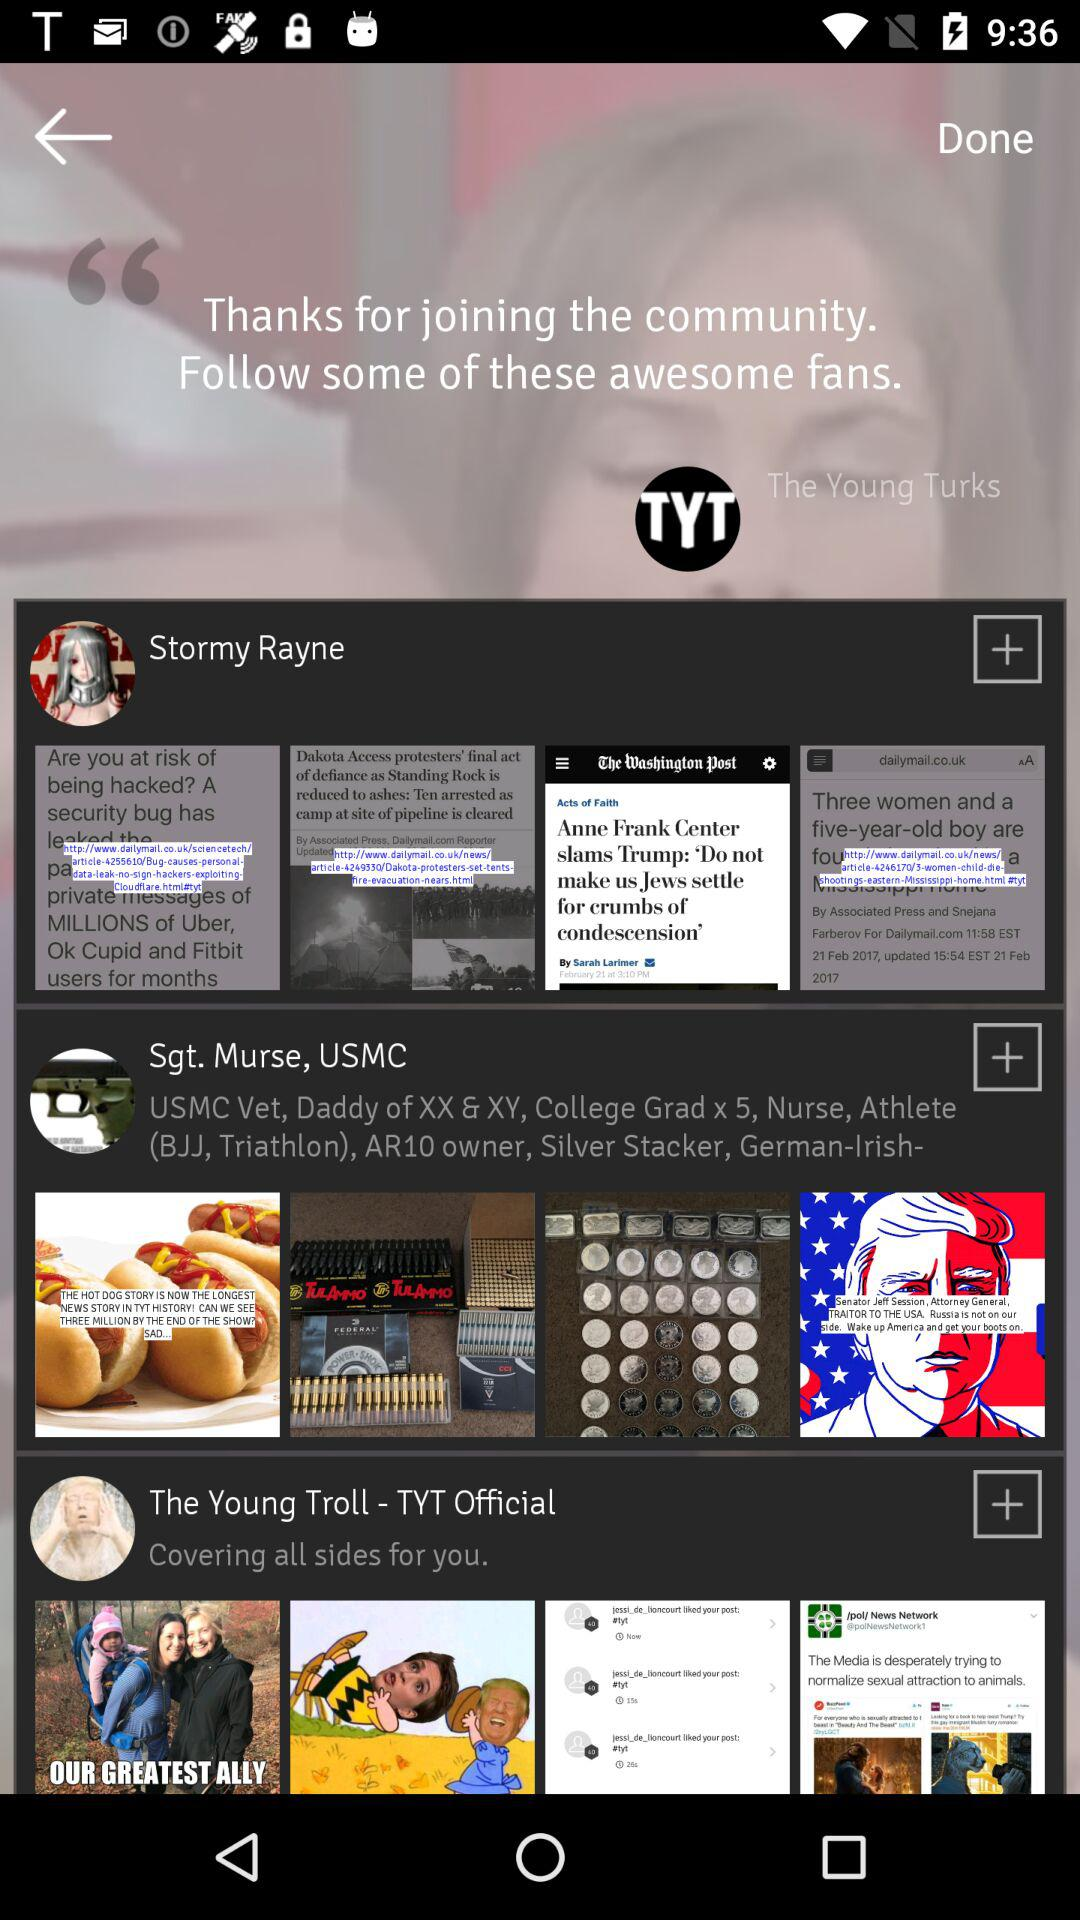When was Stormy Rayne's most recent post?
When the provided information is insufficient, respond with <no answer>. <no answer> 